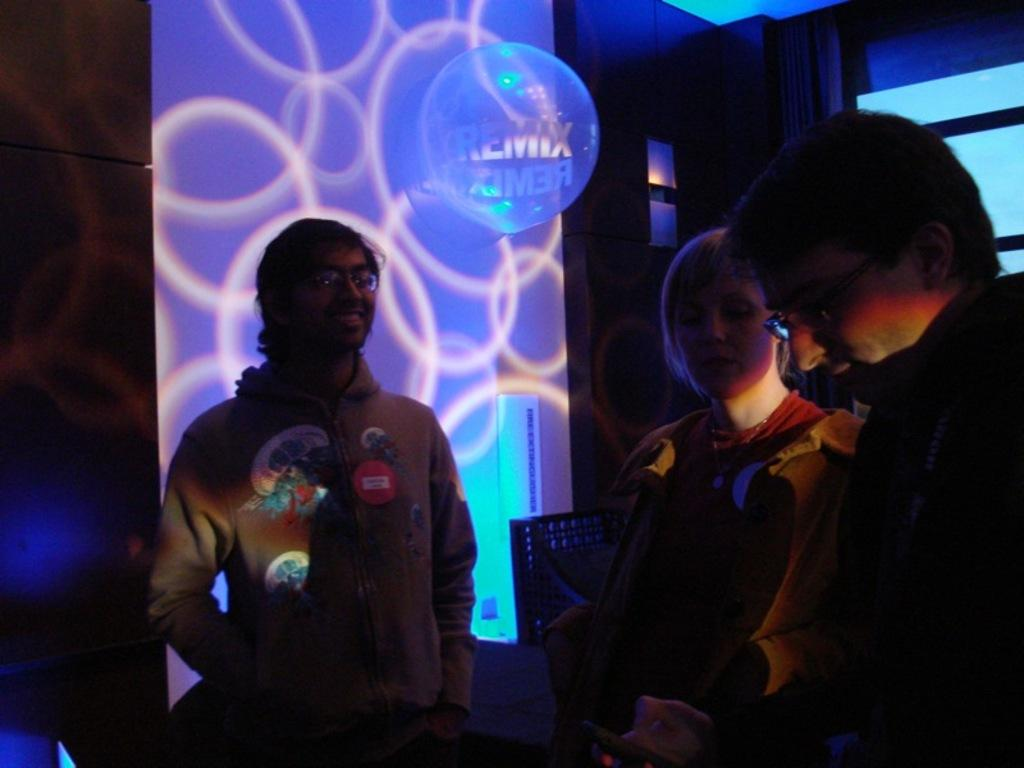How many people are present in the image? There are three people in the image. What are the people wearing? The people are wearing dresses. What can be seen in the background of the image? There is a wall in the background of the image. What is the purpose of the light in the image? The light is focused on the wall in the image. Can you tell me how many dolls are running in the image? There are no dolls or running depicted in the image; it features three people wearing dresses with a wall and a focused light in the background. 